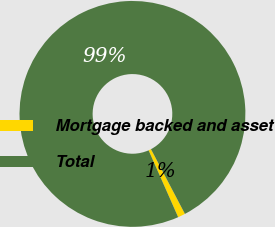<chart> <loc_0><loc_0><loc_500><loc_500><pie_chart><fcel>Mortgage backed and asset<fcel>Total<nl><fcel>1.06%<fcel>98.94%<nl></chart> 